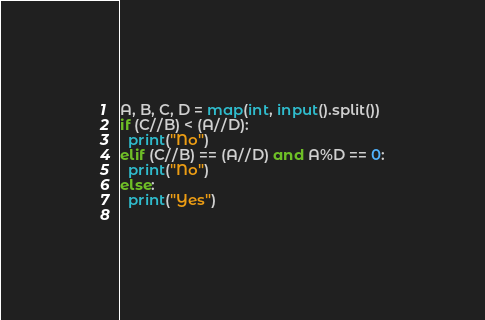<code> <loc_0><loc_0><loc_500><loc_500><_Python_>A, B, C, D = map(int, input().split())
if (C//B) < (A//D):
  print("No")
elif (C//B) == (A//D) and A%D == 0:
  print("No")
else:
  print("Yes")
  </code> 